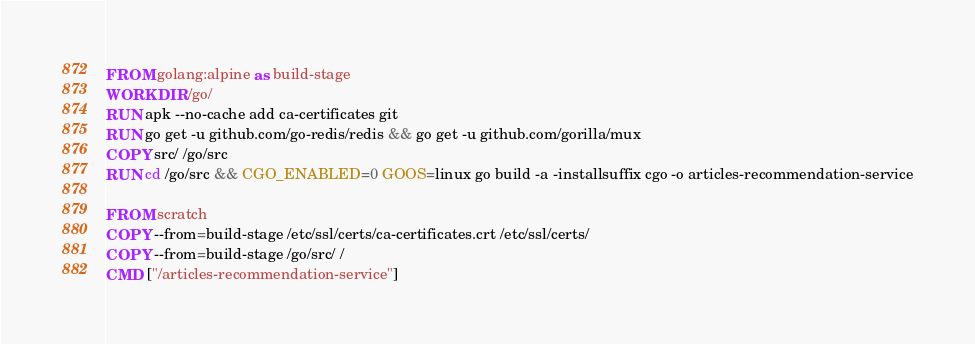Convert code to text. <code><loc_0><loc_0><loc_500><loc_500><_Dockerfile_>FROM golang:alpine as build-stage
WORKDIR /go/
RUN apk --no-cache add ca-certificates git
RUN go get -u github.com/go-redis/redis && go get -u github.com/gorilla/mux
COPY src/ /go/src
RUN cd /go/src && CGO_ENABLED=0 GOOS=linux go build -a -installsuffix cgo -o articles-recommendation-service

FROM scratch
COPY --from=build-stage /etc/ssl/certs/ca-certificates.crt /etc/ssl/certs/
COPY --from=build-stage /go/src/ /
CMD ["/articles-recommendation-service"]</code> 